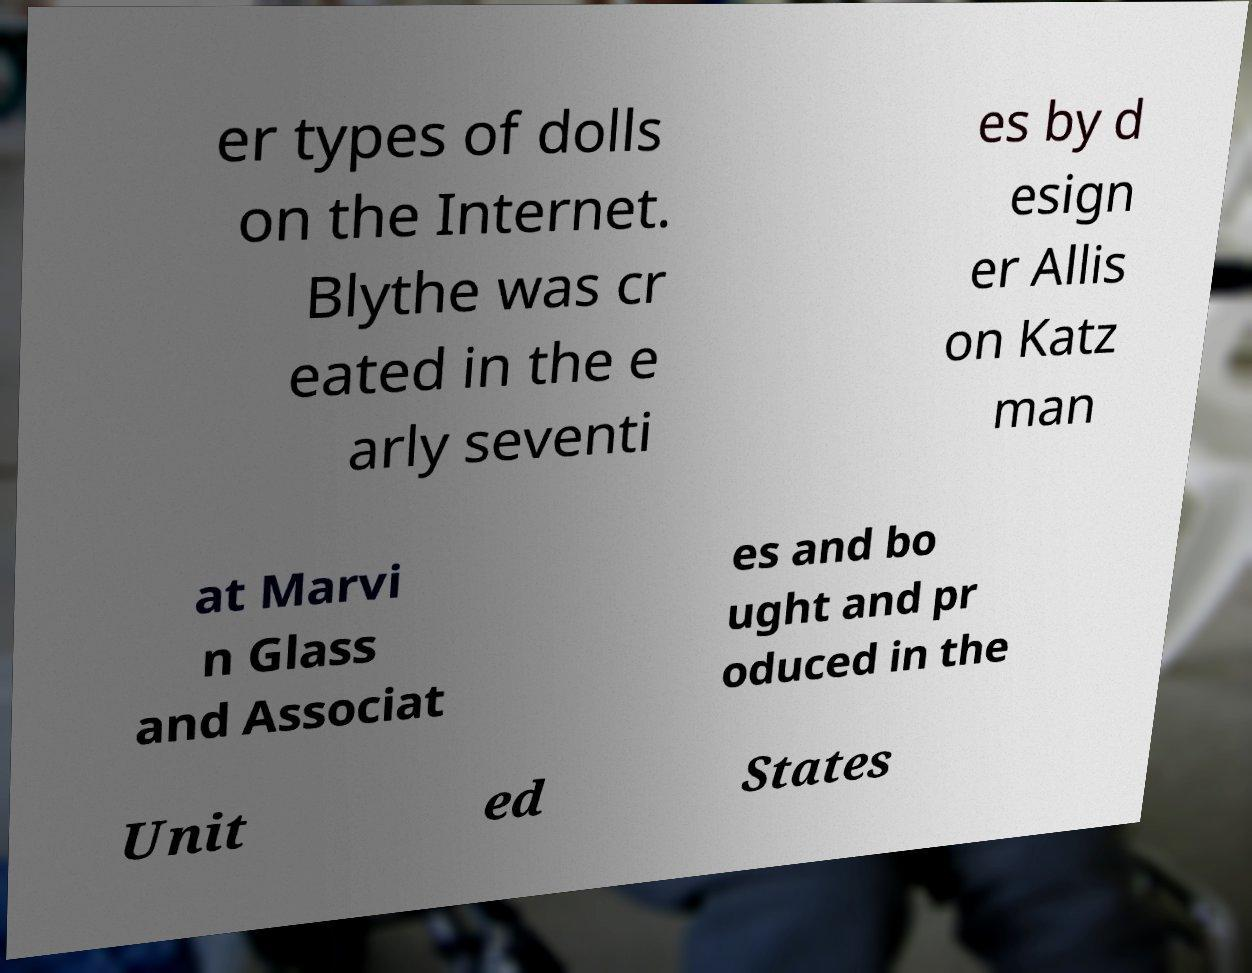What messages or text are displayed in this image? I need them in a readable, typed format. er types of dolls on the Internet. Blythe was cr eated in the e arly seventi es by d esign er Allis on Katz man at Marvi n Glass and Associat es and bo ught and pr oduced in the Unit ed States 